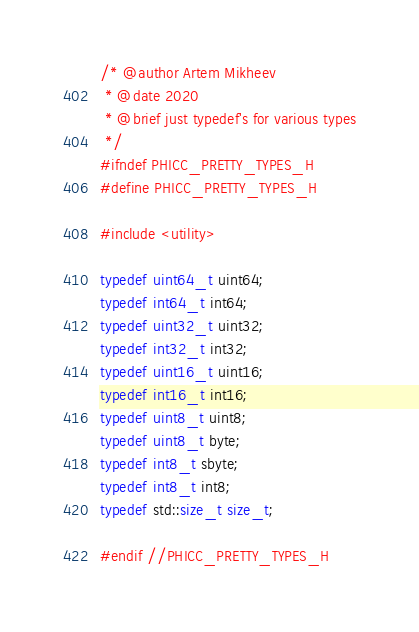<code> <loc_0><loc_0><loc_500><loc_500><_C_>/* @author Artem Mikheev
 * @date 2020
 * @brief just typedef's for various types
 */
#ifndef PHICC_PRETTY_TYPES_H
#define PHICC_PRETTY_TYPES_H

#include <utility>

typedef uint64_t uint64;
typedef int64_t int64;
typedef uint32_t uint32;
typedef int32_t int32;
typedef uint16_t uint16;
typedef int16_t int16;
typedef uint8_t uint8;
typedef uint8_t byte;
typedef int8_t sbyte;
typedef int8_t int8;
typedef std::size_t size_t;

#endif //PHICC_PRETTY_TYPES_H
</code> 